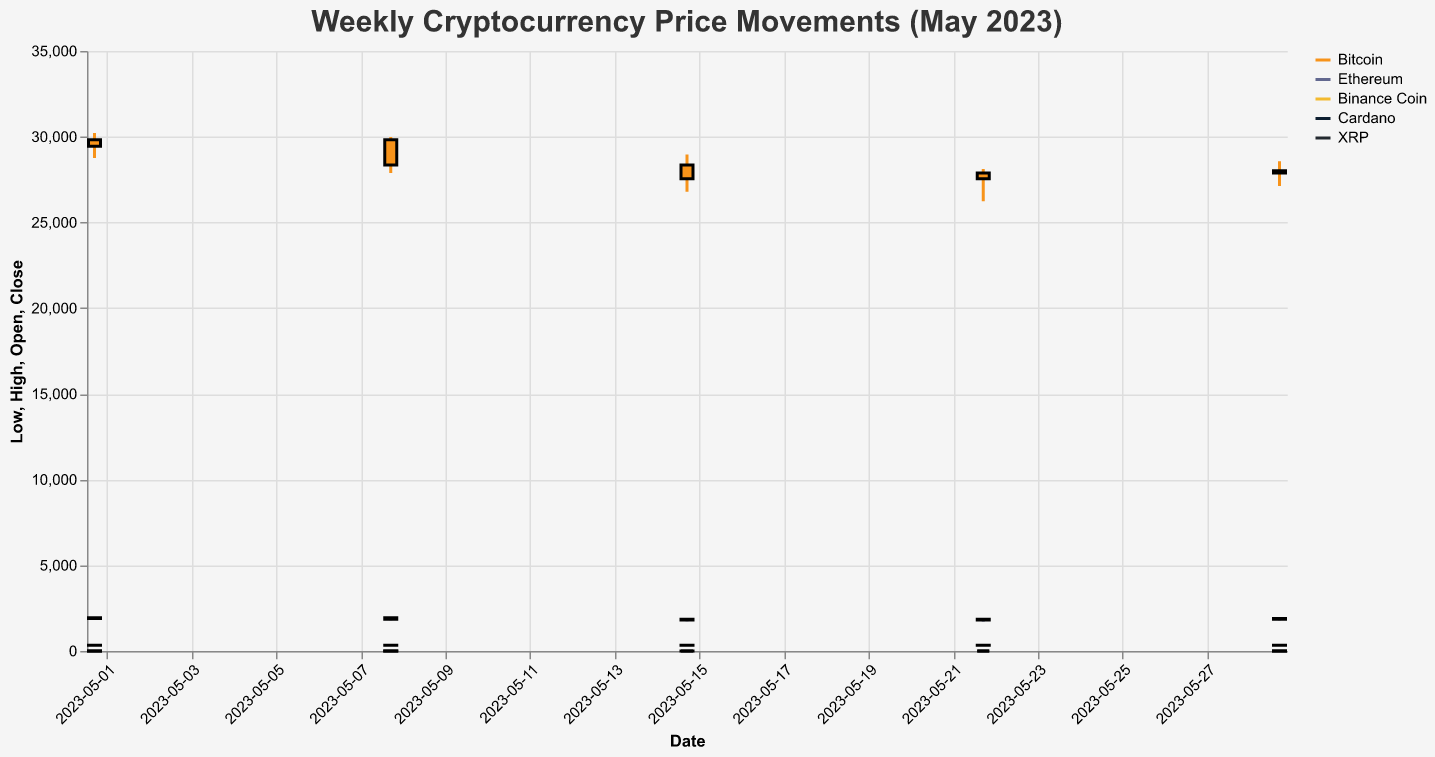Which currency had the highest closing price in the first week of May 2023? Look at the closing prices for the first week of May. Bitcoin closes at 29823.45, Ethereum at 1945.67, Binance Coin at 338.90, Cardano at 0.4012, and XRP at 0.4789. The highest closing price is from Bitcoin.
Answer: Bitcoin Which week in May did Ethereum experience its highest volatility? Volatility can be estimated by the range between the high and low prices. The weeks have ranges: May 1 (1987.56-1823.45=164.11), May 8 (1978.90-1789.34=189.56), May 15 (1923.45-1734.56=188.89), May 22 (1867.89-1723.45=144.44), May 29 (1912.34-1789.23=123.11). The highest volatility is in the week of May 8.
Answer: Week of May 8 Which currency showed an increase in closing price from the second to the third week of May? Compare the closing prices of the second week to the third week. Bitcoin decreases (28356.78 to 27543.19), Ethereum decreases (1856.78 to 1812.34), Binance Coin decreases (335.67 to 331.23), Cardano decreases (0.3945 to 0.3912), and XRP decreases (0.4723 to 0.4678). None show an increase.
Answer: None What is the average closing price of Binance Coin during May 2023? Sum the closing prices for Binance Coin in May: (338.90 + 335.67 + 331.23 + 334.56 + 337.45) = 1677.81. Divide by the number of weeks (5) to get the average: 1677.81/5.
Answer: 335.56 Between Bitcoin and Ethereum, which currency had a lower lowest price in May 2023? Compare the lowest prices of Bitcoin and Ethereum in May. Bitcoin’s low points are 28756.33, 27890.11, 26789.22, 26234.87, and 27123.45. Ethereum’s low points are 1823.45, 1789.34, 1734.56, 1723.45, and 1789.23. Ethereum’s lowest (1734.56) is lower than Bitcoin’s lowest (26234.87).
Answer: Ethereum In which week did Cardano have its highest high price? Look at the high prices for Cardano in each week: May 1 (0.4123), May 8 (0.4078), May 15 (0.4034), May 22 (0.3989), May 29 (0.4067). The highest high price is in the first week.
Answer: Week of May 1 Which currency had the smallest range between high and low prices in the last week of May 2023? Calculate the range for the last week: Bitcoin (28567.89-27123.45=1444.44), Ethereum (1912.34-1789.23=123.11), Binance Coin (341.23-329.78=11.45), Cardano (0.4067-0.3890=0.0177), XRP (0.4823-0.4645=0.0178). Cardano has the smallest range.
Answer: Cardano Did XRP's closing price increase or decrease from the first to the last week of May 2023? Compare XRP’s closing prices from the first week (0.4789) to the last week (0.4778). The closing price decreased.
Answer: Decrease 